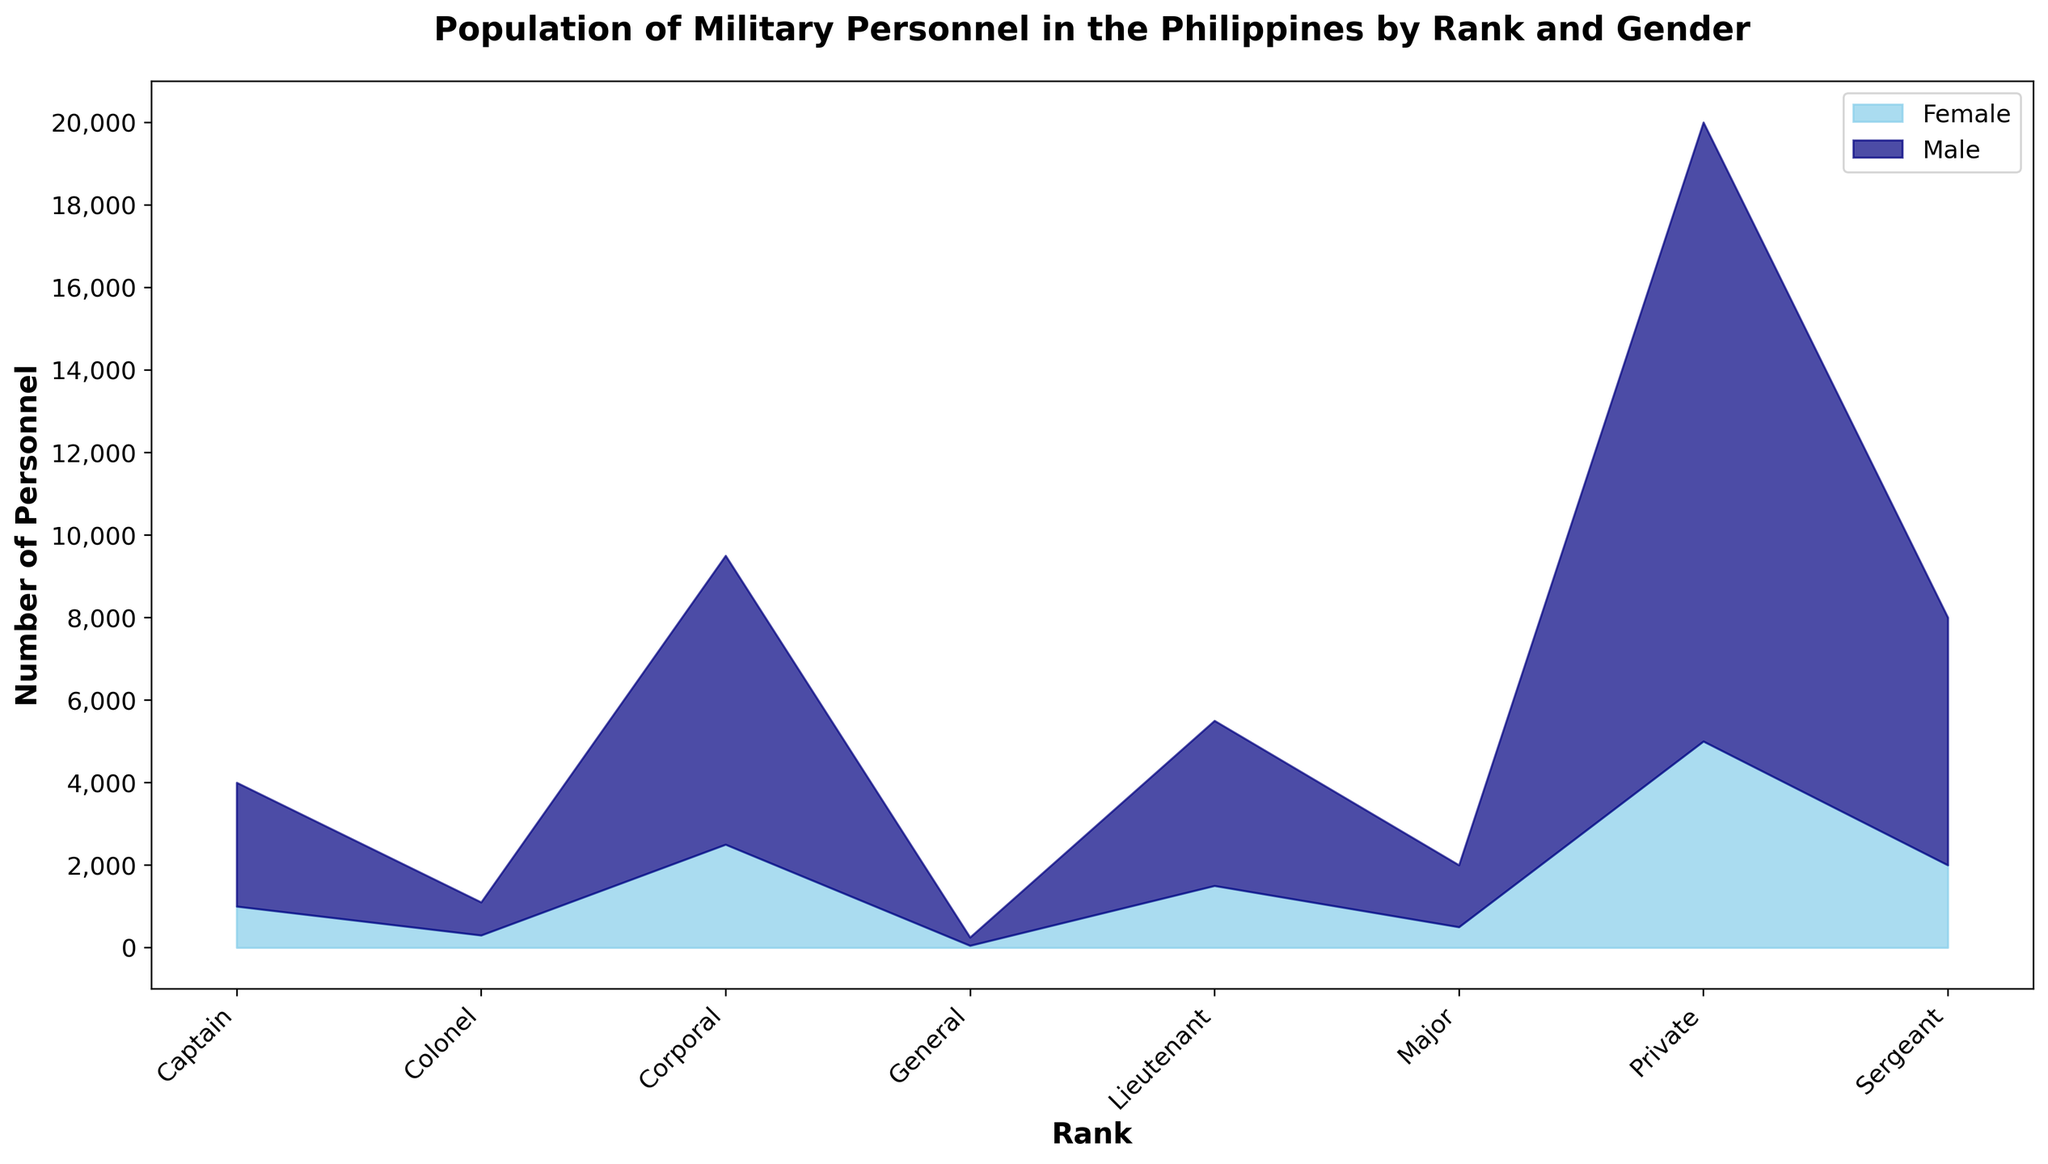What is the total number of female military personnel of all ranks? To find the total number of female personnel, sum the counts of female personnel across all ranks: 5000 (Private) + 2500 (Corporal) + 2000 (Sergeant) + 1500 (Lieutenant) + 1000 (Captain) + 500 (Major) + 300 (Colonel) + 50 (General). The calculation gives 5000 + 2500 + 2000 + 1500 + 1000 + 500 + 300 + 50 = 12,850.
Answer: 12,850 Which rank has the highest number of male personnel? To determine this, look at the number of male personnel across each rank and identify the highest value. The counts are 15000 (Private), 7000 (Corporal), 6000 (Sergeant), 4000 (Lieutenant), 3000 (Captain), 1500 (Major), 800 (Colonel), 200 (General). The highest value is 15,000, which corresponds to the rank of Private.
Answer: Private What is the difference between the number of male and female personnel at the rank of Captain? Identify the counts for male and female personnel at the rank of Captain. Male personnel count is 3000, and female personnel count is 1000. Subtract the female count from the male count: 3000 - 1000 = 2000.
Answer: 2000 What is the cumulative number of personnel (male + female) at the rank of Major? Add the counts of both male and female personnel at the rank of Major. Male personnel: 1500 and female personnel: 500. So, 1500 + 500 = 2000.
Answer: 2000 Which rank shows the smallest difference in the number of male and female personnel? Calculate the difference for each rank:
Private: 15000 - 5000 = 10000
Corporal: 7000 - 2500 = 4500
Sergeant: 6000 - 2000 = 4000
Lieutenant: 4000 - 1500 = 2500
Captain: 3000 - 1000 = 2000
Major: 1500 - 500 = 1000
Colonel: 800 - 300 = 500
General: 200 - 50 = 150
The smallest difference is 150 for the rank of General.
Answer: General How does the number of male personnel compare between Corporal and Lieutenant? Look at the number of male personnel for Corporal (7000) and Lieutenant (4000). Compare these values: 7000 (Corporal) is greater than 4000 (Lieutenant).
Answer: More in Corporal Which rank has the highest proportion of female personnel relative to male personnel? Compute the proportion for each rank:
Private: 5000/15000 = 1/3
Corporal: 2500/7000 ≈ 0.357
Sergeant: 2000/6000 = 1/3
Lieutenant: 1500/4000 = 0.375
Captain: 1000/3000 = 1/3
Major: 500/1500 ≈ 0.333
Colonel: 300/800 ≈ 0.375
General: 50/200 = 0.25
For Corporal, the proportion is ≈ 0.357. For Lieutenant, the proportion is 0.375. The highest proportion is for Lieutenant and Colonel at 0.375.
Answer: Lieutenant and Colonel Which rank has the highest total number of personnel (both male and female)? Total the counts for each rank:
Private: 15000 + 5000 = 20000
Corporal: 7000 + 2500 = 9500
Sergeant: 6000 + 2000 = 8000
Lieutenant: 4000 + 1500 = 5500
Captain: 3000 + 1000 = 4000
Major: 1500 + 500 = 2000
Colonel: 800 + 300 = 1100
General: 200 + 50 = 250
The highest total is for Privates, 20000.
Answer: Private 